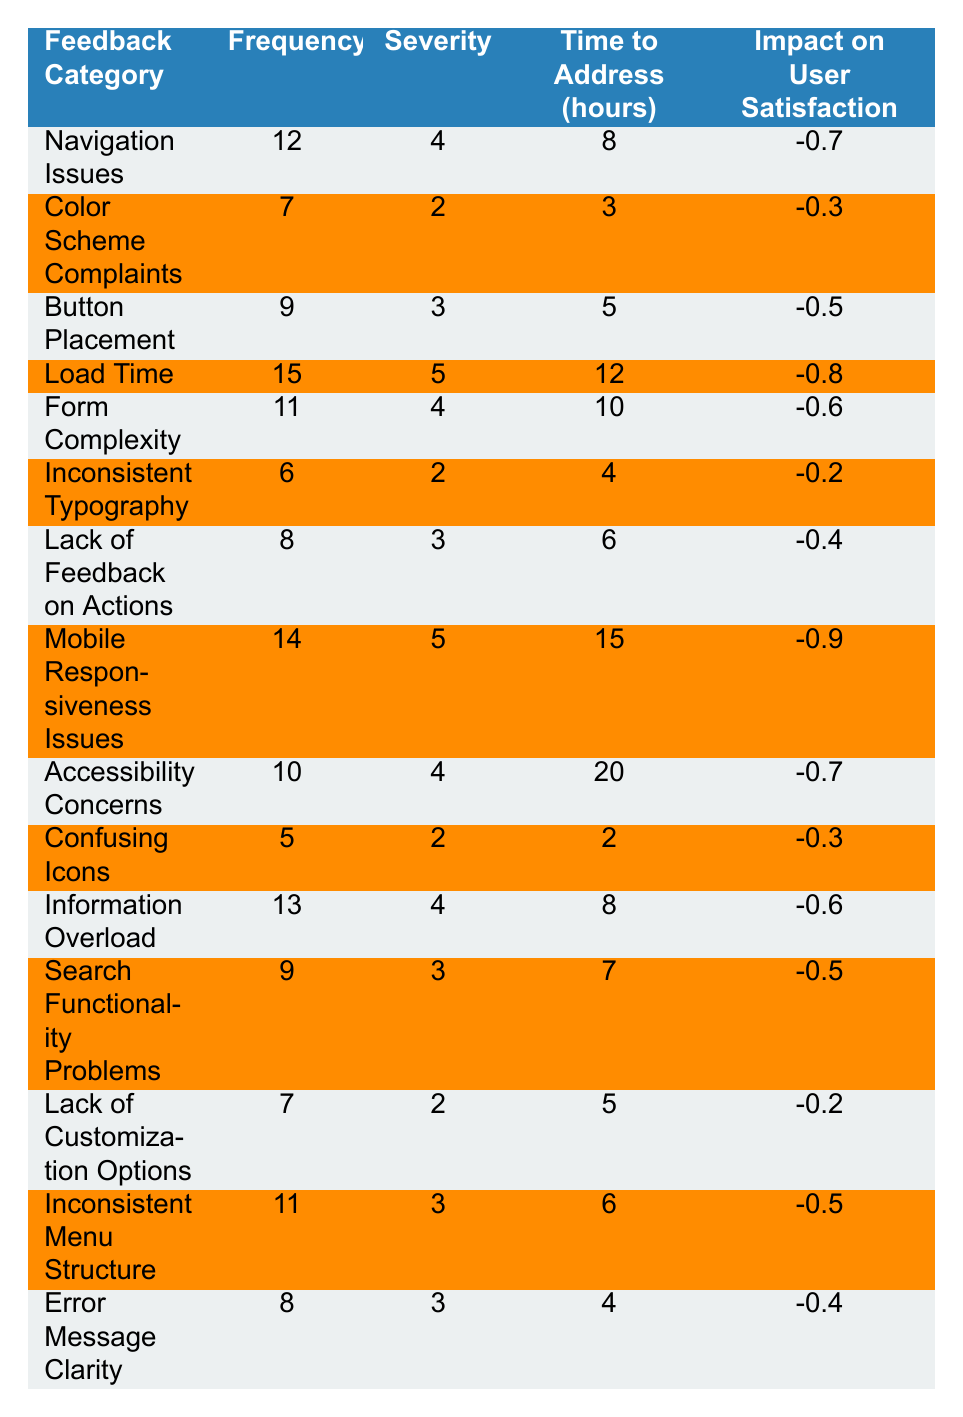What is the frequency of Navigation Issues? The table lists Navigation Issues with a frequency value of 12 located in the second column.
Answer: 12 Which feedback category has the highest severity rating? By comparing the severity ratings, Load Time has the highest value of 5, as indicated in the third column.
Answer: Load Time How many hours are estimated to address Mobile Responsiveness Issues? The Time to Address for Mobile Responsiveness Issues is 15 hours, listed in the fourth column.
Answer: 15 What is the average impact on user satisfaction for the issues with a severity of 4? The total impact for severity of 4 includes -0.7 (Navigation Issues), -0.6 (Form Complexity), -0.7 (Accessibility Concerns), and -0.6 (Information Overload), which gives a total of -2.6 for 4 occurrences. The average is -2.6/4 = -0.65.
Answer: -0.65 Is there a feedback category with a frequency greater than 10 and a severity of 3? By checking the frequency and severity columns, Button Placement (9,3), Search Functionality Problems (9,3) are less than or equal to 10, while Mobile Responsiveness Issues (14,5) and Load Time (15,5) have severity of 5. Thus, there are no categories with frequency > 10 and severity of 3.
Answer: No What is the total time required to address all feedback categories with a frequency greater than 10? The relevant categories are Load Time (12), Mobile Responsiveness Issues (15), and Navigation Issues (8). Adding these gives 12 + 15 + 8 = 35 hours.
Answer: 35 Which two feedback categories have the least impact on user satisfaction? The feedback categories with the least impact are Confusing Icons (-0.3) and Lack of Customization Options (-0.2), the values identified in the fifth column.
Answer: Confusing Icons and Lack of Customization Options If we were to rank the issues by severity, which feedback category comes third? The feedback categories ranked by severity are Load Time (5), Mobile Responsiveness Issues (5), and then Navigation Issues (4) as the third category.
Answer: Navigation Issues What is the difference in frequency between the feedback category with the highest frequency and the one with the lowest? The highest frequency is 15 (Load Time) and the lowest frequency is 5 (Confusing Icons), giving a difference of 15 - 5 = 10.
Answer: 10 Which feedback category requires the most time to address? The feedback category that requires the most time to address is Accessibility Concerns, taking 20 hours as noted in the table.
Answer: Accessibility Concerns 